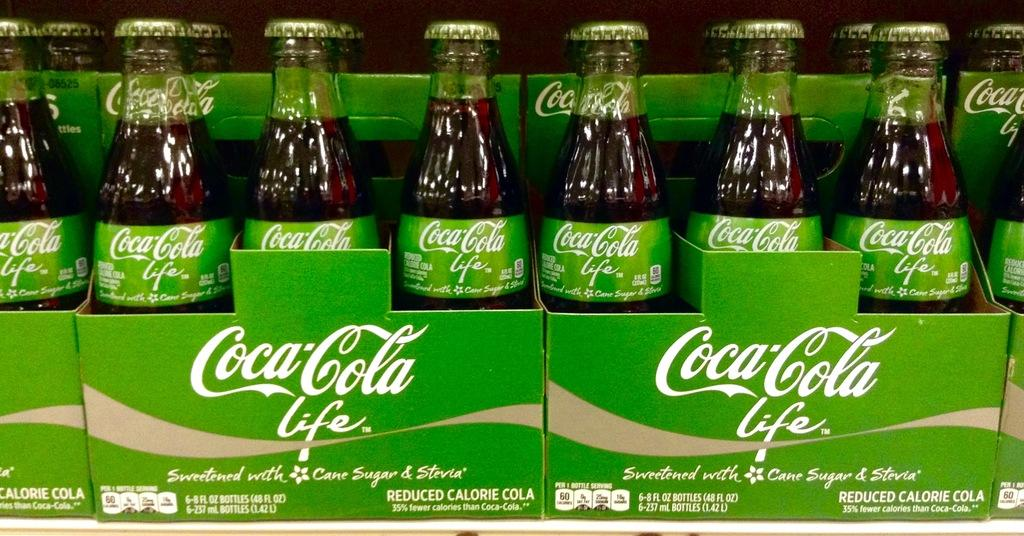<image>
Create a compact narrative representing the image presented. Six packs of Coca-Cola Life sweetened with cane sugar and stevia soda. 